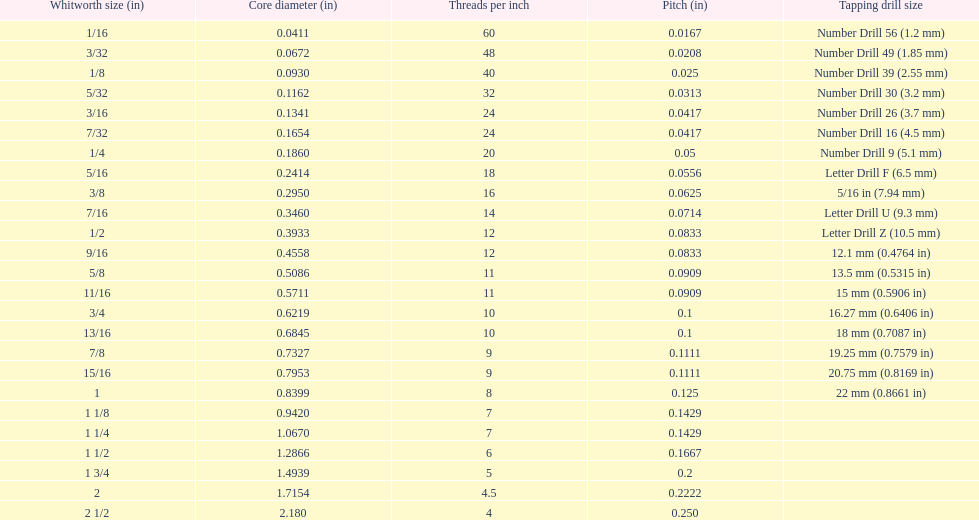What is the core diameter of a 1/16 whitworth size? 0.0411. Which whitworth dimension has a matching pitch with a 1/2? 9/16. What size has an equal number of threads as a 3/16 whitworth? 7/32. 